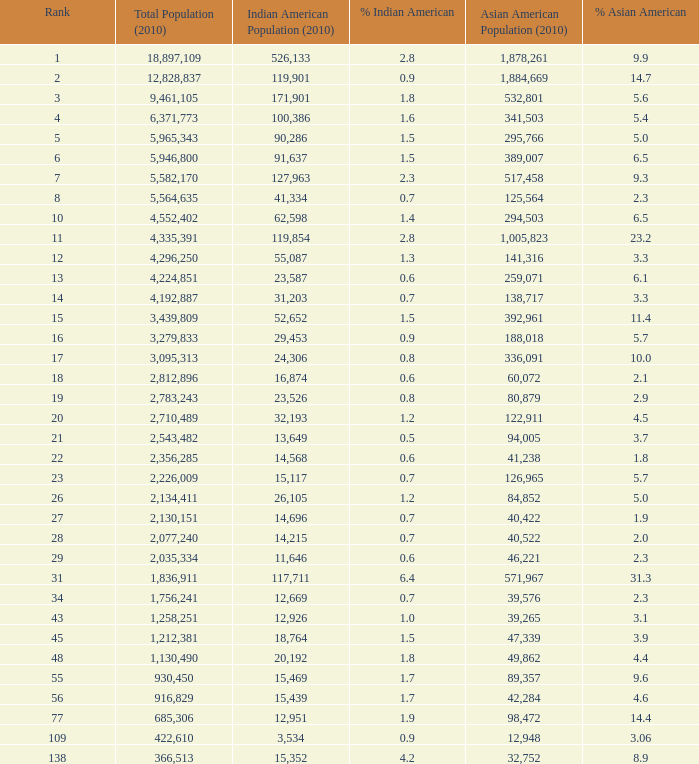What's the total population when the Asian American population is less than 60,072, the Indian American population is more than 14,696 and is 4.2% Indian American? 366513.0. 